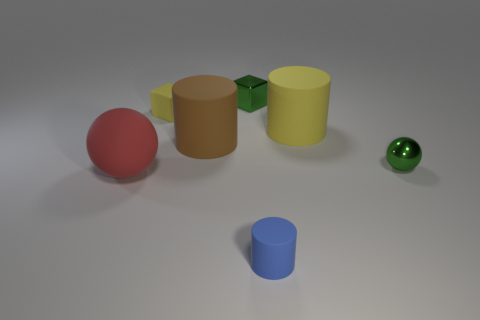Add 1 big gray metal cubes. How many objects exist? 8 Subtract all cylinders. How many objects are left? 4 Subtract 0 gray cylinders. How many objects are left? 7 Subtract all small matte blocks. Subtract all tiny rubber cylinders. How many objects are left? 5 Add 5 big things. How many big things are left? 8 Add 3 tiny purple shiny spheres. How many tiny purple shiny spheres exist? 3 